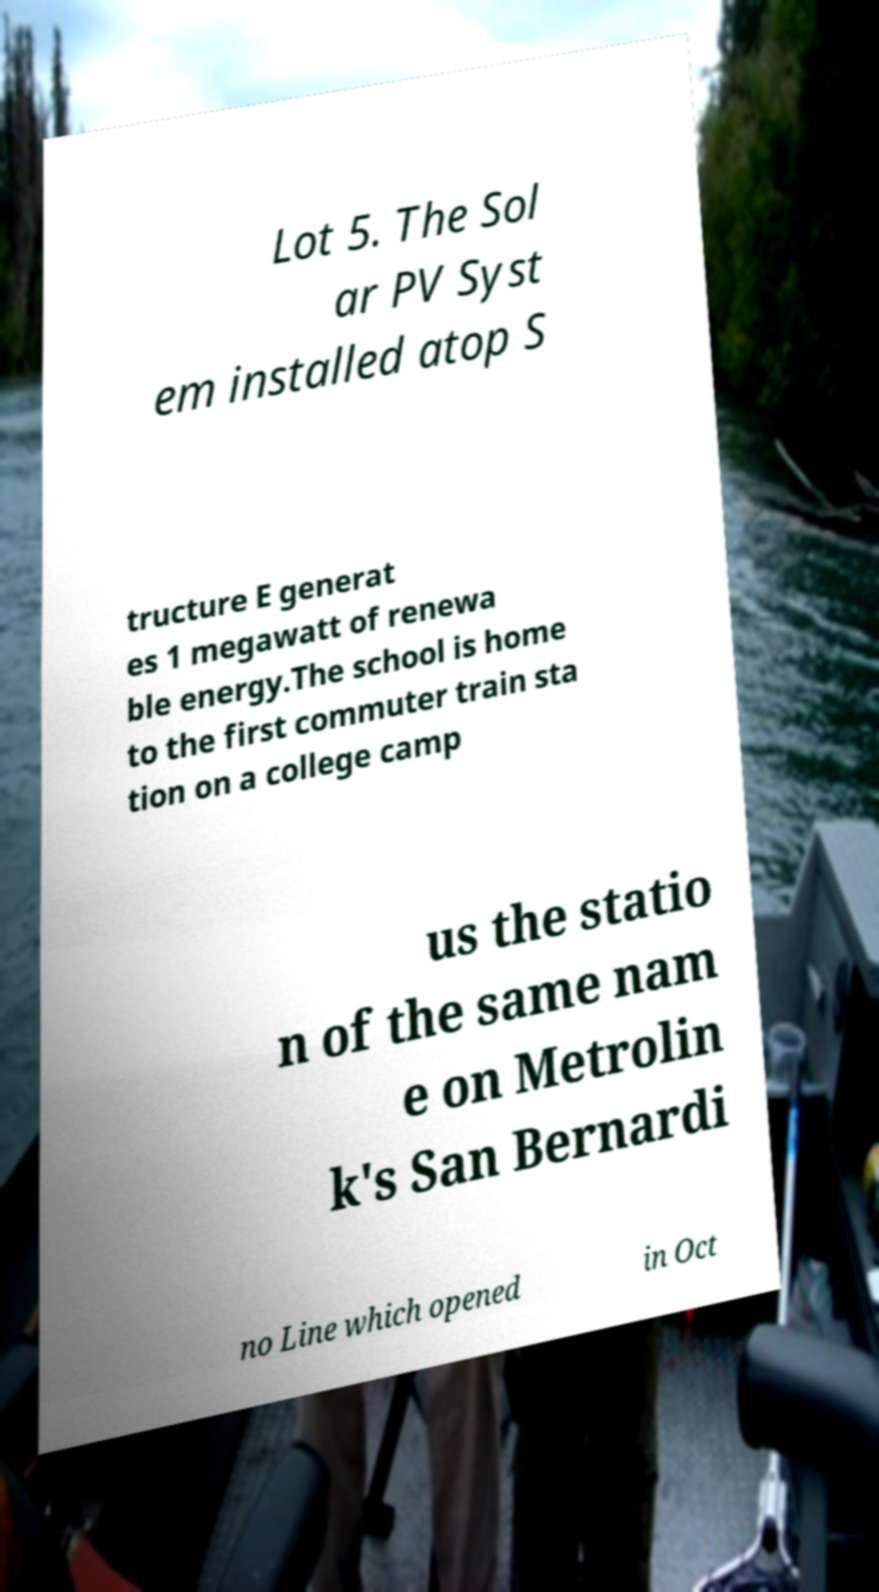Can you accurately transcribe the text from the provided image for me? Lot 5. The Sol ar PV Syst em installed atop S tructure E generat es 1 megawatt of renewa ble energy.The school is home to the first commuter train sta tion on a college camp us the statio n of the same nam e on Metrolin k's San Bernardi no Line which opened in Oct 